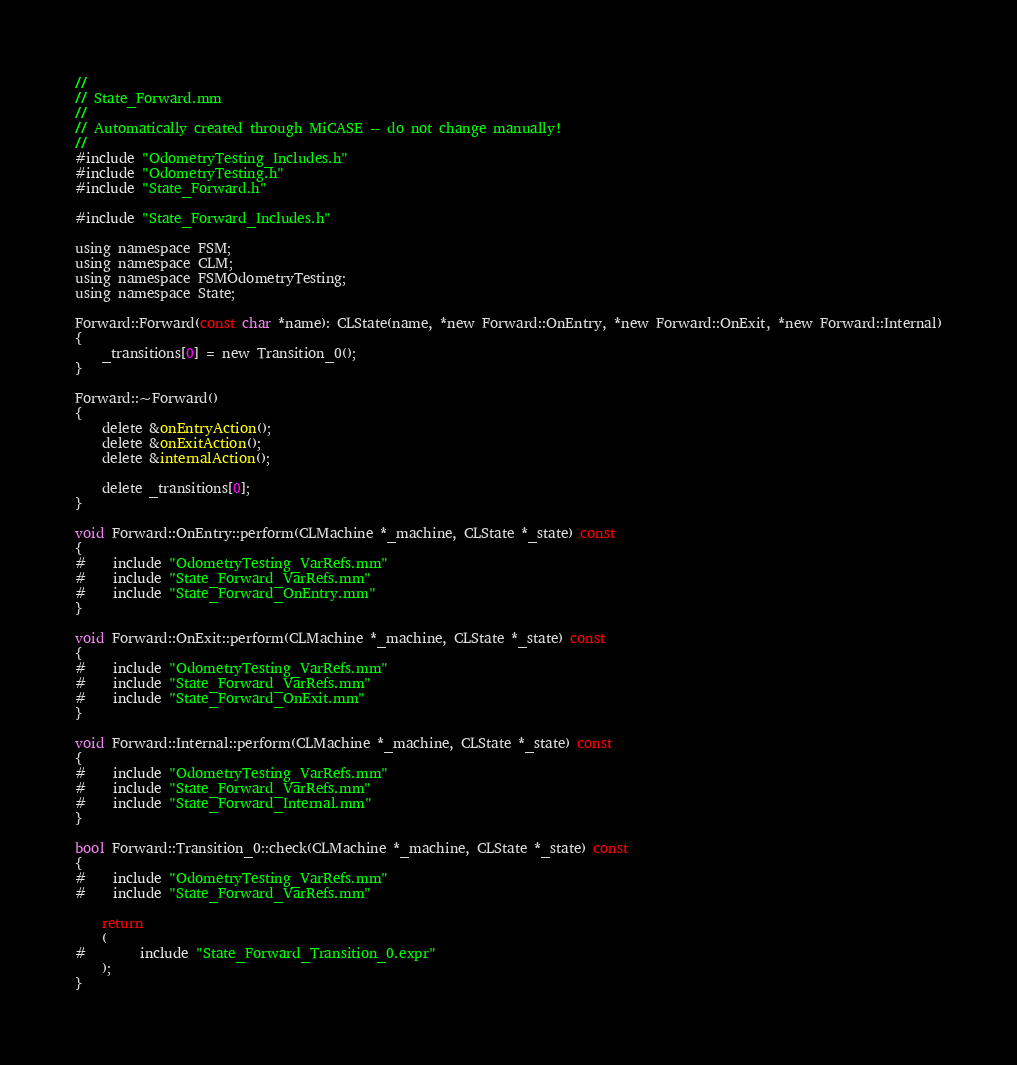Convert code to text. <code><loc_0><loc_0><loc_500><loc_500><_ObjectiveC_>//
// State_Forward.mm
//
// Automatically created through MiCASE -- do not change manually!
//
#include "OdometryTesting_Includes.h"
#include "OdometryTesting.h"
#include "State_Forward.h"

#include "State_Forward_Includes.h"

using namespace FSM;
using namespace CLM;
using namespace FSMOdometryTesting;
using namespace State;

Forward::Forward(const char *name): CLState(name, *new Forward::OnEntry, *new Forward::OnExit, *new Forward::Internal)
{
	_transitions[0] = new Transition_0();
}

Forward::~Forward()
{
	delete &onEntryAction();
	delete &onExitAction();
	delete &internalAction();

	delete _transitions[0];
}

void Forward::OnEntry::perform(CLMachine *_machine, CLState *_state) const
{
#	include "OdometryTesting_VarRefs.mm"
#	include "State_Forward_VarRefs.mm"
#	include "State_Forward_OnEntry.mm"
}

void Forward::OnExit::perform(CLMachine *_machine, CLState *_state) const
{
#	include "OdometryTesting_VarRefs.mm"
#	include "State_Forward_VarRefs.mm"
#	include "State_Forward_OnExit.mm"
}

void Forward::Internal::perform(CLMachine *_machine, CLState *_state) const
{
#	include "OdometryTesting_VarRefs.mm"
#	include "State_Forward_VarRefs.mm"
#	include "State_Forward_Internal.mm"
}

bool Forward::Transition_0::check(CLMachine *_machine, CLState *_state) const
{
#	include "OdometryTesting_VarRefs.mm"
#	include "State_Forward_VarRefs.mm"

	return
	(
#		include "State_Forward_Transition_0.expr"
	);
}
</code> 